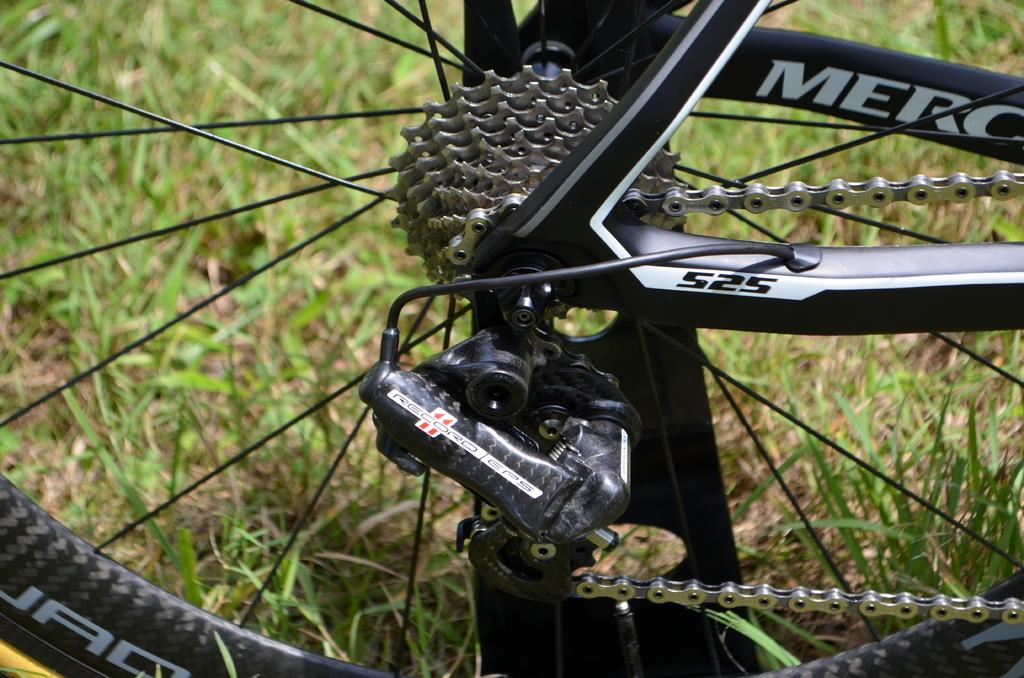What object is featured in the image? There is a wheel of a cycle in the image. What type of terrain is visible behind the wheel? There is grass visible behind the wheel. How many fruits are hanging from the wheel in the image? There are no fruits present in the image; it features a wheel of a cycle and grass. 